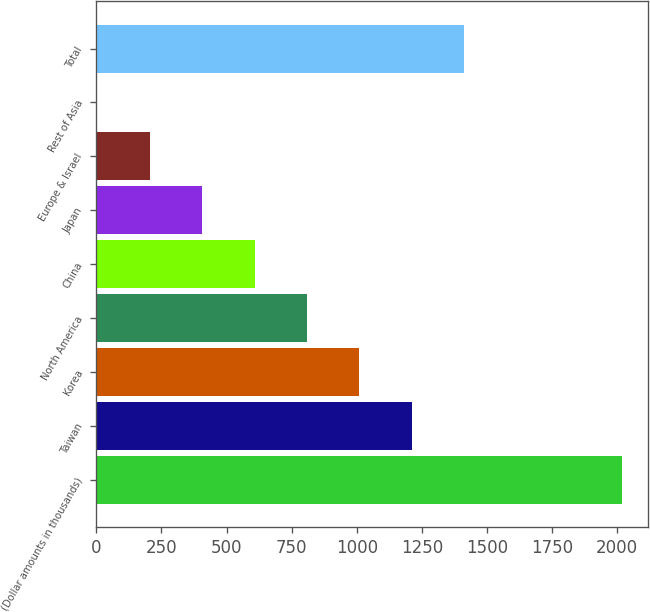Convert chart. <chart><loc_0><loc_0><loc_500><loc_500><bar_chart><fcel>(Dollar amounts in thousands)<fcel>Taiwan<fcel>Korea<fcel>North America<fcel>China<fcel>Japan<fcel>Europe & Israel<fcel>Rest of Asia<fcel>Total<nl><fcel>2017<fcel>1211.8<fcel>1010.5<fcel>809.2<fcel>607.9<fcel>406.6<fcel>205.3<fcel>4<fcel>1413.1<nl></chart> 